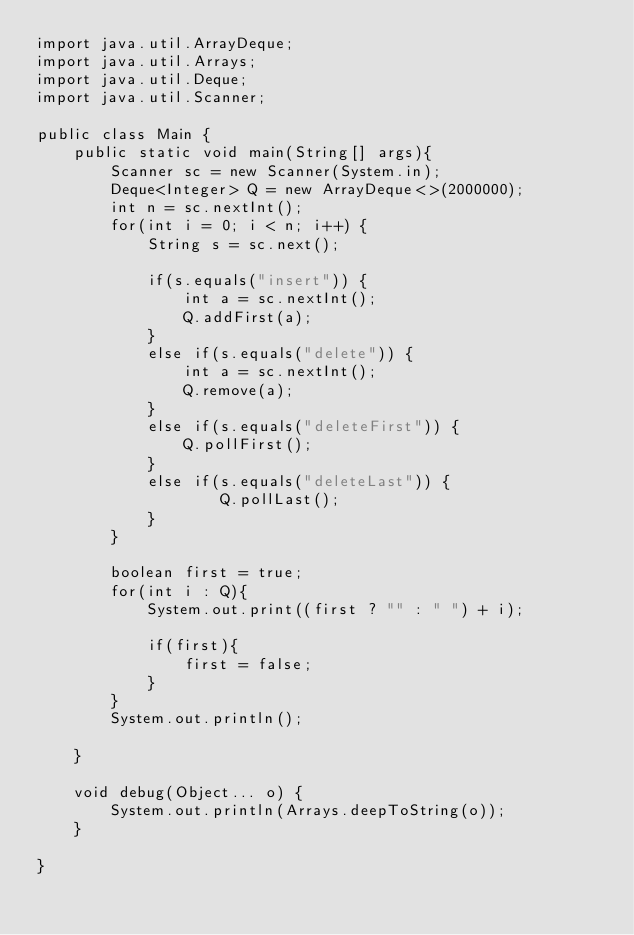<code> <loc_0><loc_0><loc_500><loc_500><_Java_>import java.util.ArrayDeque;
import java.util.Arrays;
import java.util.Deque;
import java.util.Scanner;

public class Main {
	public static void main(String[] args){
		Scanner sc = new Scanner(System.in);
		Deque<Integer> Q = new ArrayDeque<>(2000000);
		int n = sc.nextInt();
		for(int i = 0; i < n; i++) {
			String s = sc.next();
			
			if(s.equals("insert")) {
				int a = sc.nextInt();
				Q.addFirst(a);
			}
			else if(s.equals("delete")) {
				int a = sc.nextInt();
				Q.remove(a);
			}
			else if(s.equals("deleteFirst")) {
				Q.pollFirst();
			}
			else if(s.equals("deleteLast")) {
					Q.pollLast();
			}	
		}

        boolean first = true;
        for(int i : Q){
            System.out.print((first ? "" : " ") + i);
             
            if(first){
                first = false;
            }
        }
        System.out.println();

	}

	void debug(Object... o) {
		System.out.println(Arrays.deepToString(o));
	}

}
</code> 